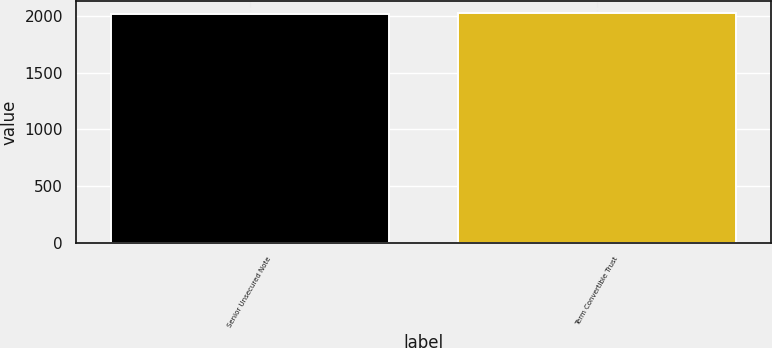<chart> <loc_0><loc_0><loc_500><loc_500><bar_chart><fcel>Senior Unsecured Note<fcel>Term Convertible Trust<nl><fcel>2014<fcel>2029<nl></chart> 